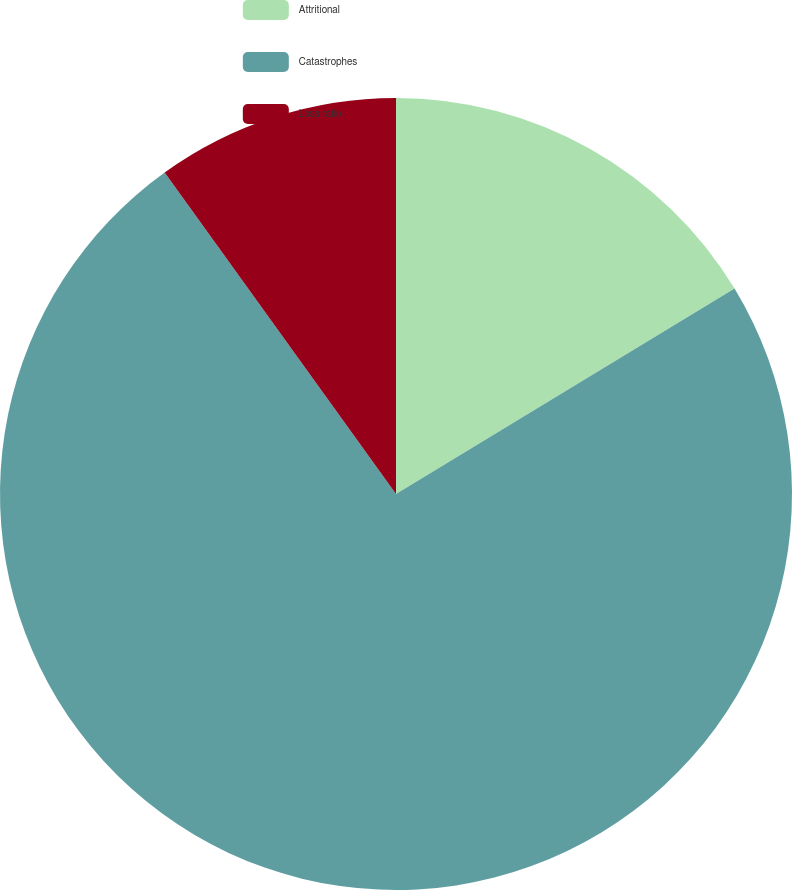Convert chart. <chart><loc_0><loc_0><loc_500><loc_500><pie_chart><fcel>Attritional<fcel>Catastrophes<fcel>Loss ratio<nl><fcel>16.32%<fcel>73.75%<fcel>9.93%<nl></chart> 